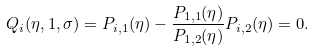Convert formula to latex. <formula><loc_0><loc_0><loc_500><loc_500>Q _ { i } ( \eta , 1 , \sigma ) = P _ { i , 1 } ( \eta ) - \frac { P _ { 1 , 1 } ( \eta ) } { P _ { 1 , 2 } ( \eta ) } P _ { i , 2 } ( \eta ) = 0 .</formula> 